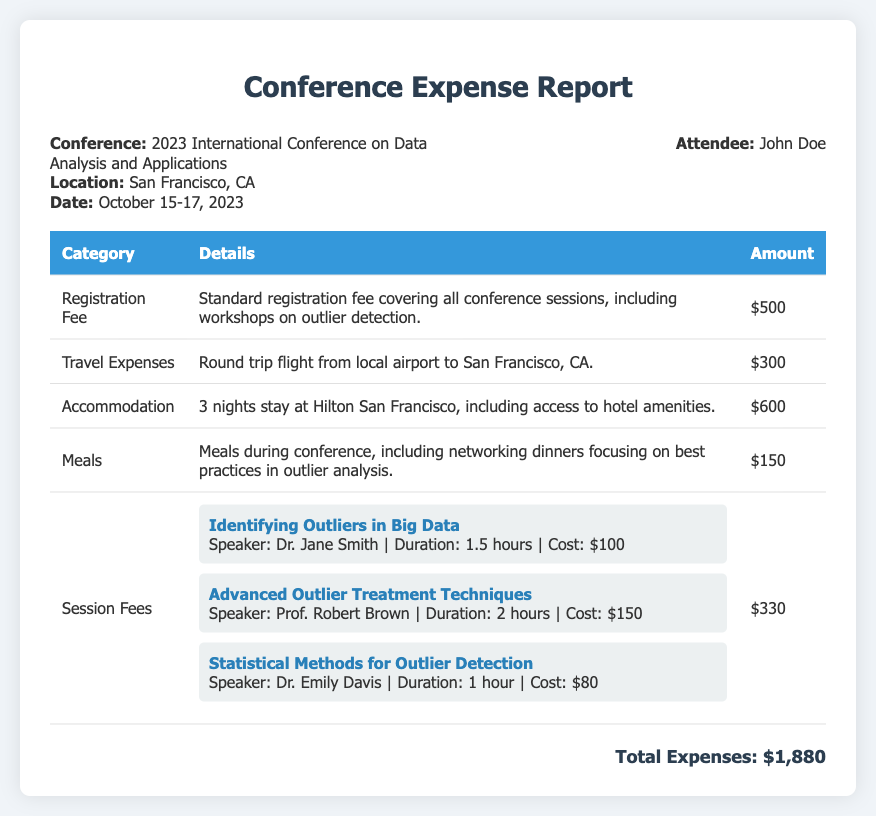What is the total amount of expenses? The total amount of expenses is provided at the bottom of the document, which sums all individual expenses.
Answer: $1,880 Who is the attendee of the conference? The attendee's name is mentioned in the header section of the document.
Answer: John Doe What city is the conference located in? The location of the conference is stated in the header of the document.
Answer: San Francisco, CA How much was spent on meals during the conference? The amount spent on meals is listed in the table under the "Meals" category.
Answer: $150 What is the cost of the session on "Advanced Outlier Treatment Techniques"? The cost of each session is detailed in the session fees section, specifically for this session.
Answer: $150 Which speaker presented the session on statistical methods for outlier detection? The speaker's name is provided along with the session details in the "Session Fees" section.
Answer: Dr. Emily Davis What was the duration of the session "Identifying Outliers in Big Data"? The duration of each session is clearly mentioned below the title in the session fees section.
Answer: 1.5 hours How many nights was accommodation booked for? The number of nights for accommodation can be inferred from the details provided in the "Accommodation" category.
Answer: 3 nights What specific topic was discussed during networking dinners? The document mentions the focus of networking dinners in the "Meals" category.
Answer: Outlier analysis 